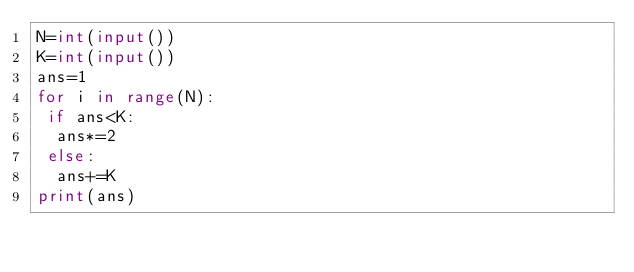Convert code to text. <code><loc_0><loc_0><loc_500><loc_500><_Python_>N=int(input())
K=int(input())
ans=1
for i in range(N):
 if ans<K:
  ans*=2
 else:
  ans+=K
print(ans)</code> 